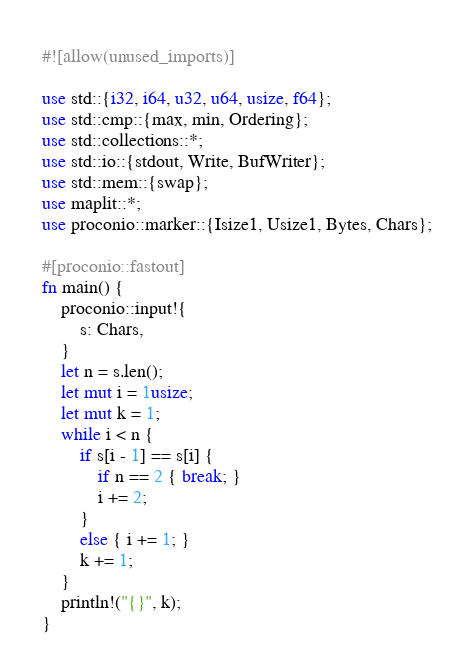<code> <loc_0><loc_0><loc_500><loc_500><_Rust_>#![allow(unused_imports)]

use std::{i32, i64, u32, u64, usize, f64};
use std::cmp::{max, min, Ordering};
use std::collections::*;
use std::io::{stdout, Write, BufWriter};
use std::mem::{swap};
use maplit::*;
use proconio::marker::{Isize1, Usize1, Bytes, Chars};

#[proconio::fastout]
fn main() {
    proconio::input!{
        s: Chars,
    }
    let n = s.len();
    let mut i = 1usize;
    let mut k = 1;
    while i < n {
        if s[i - 1] == s[i] {
            if n == 2 { break; }
            i += 2;
        }
        else { i += 1; }
        k += 1;
    }
    println!("{}", k);
}
</code> 